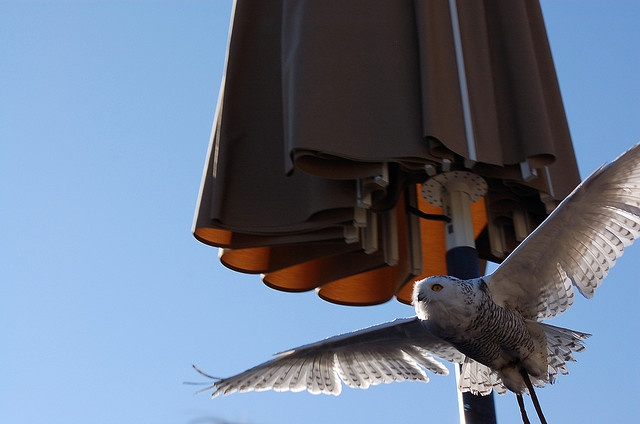Describe the objects in this image and their specific colors. I can see umbrella in lightblue, black, maroon, and gray tones and bird in lightblue, gray, black, and darkgray tones in this image. 